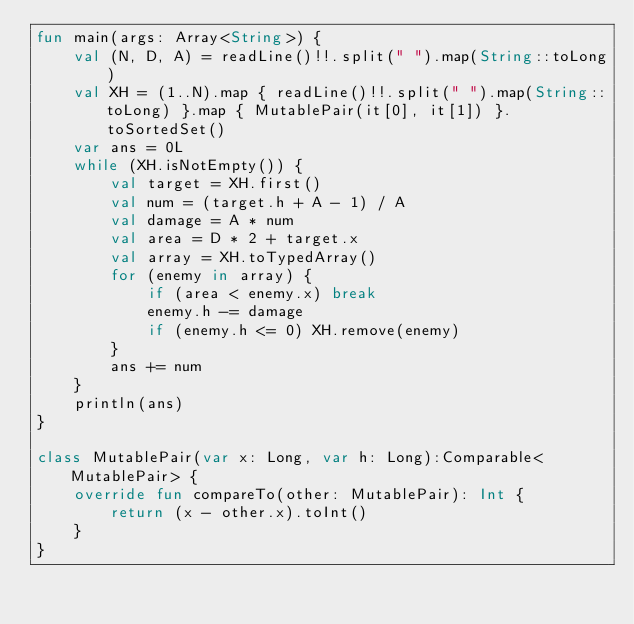Convert code to text. <code><loc_0><loc_0><loc_500><loc_500><_Kotlin_>fun main(args: Array<String>) {
    val (N, D, A) = readLine()!!.split(" ").map(String::toLong)
    val XH = (1..N).map { readLine()!!.split(" ").map(String::toLong) }.map { MutablePair(it[0], it[1]) }.toSortedSet()
    var ans = 0L
    while (XH.isNotEmpty()) {
        val target = XH.first()
        val num = (target.h + A - 1) / A
        val damage = A * num
        val area = D * 2 + target.x
        val array = XH.toTypedArray()
        for (enemy in array) {
            if (area < enemy.x) break
            enemy.h -= damage
            if (enemy.h <= 0) XH.remove(enemy)
        }
        ans += num
    }
    println(ans)
}

class MutablePair(var x: Long, var h: Long):Comparable<MutablePair> {
    override fun compareTo(other: MutablePair): Int {
        return (x - other.x).toInt()
    }
}</code> 